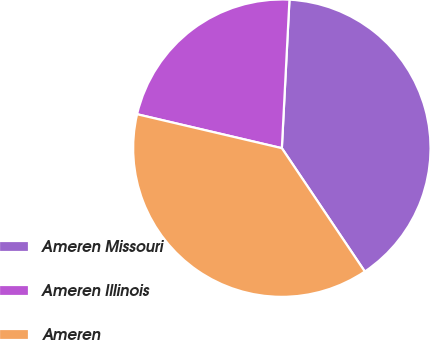Convert chart. <chart><loc_0><loc_0><loc_500><loc_500><pie_chart><fcel>Ameren Missouri<fcel>Ameren Illinois<fcel>Ameren<nl><fcel>39.76%<fcel>22.15%<fcel>38.09%<nl></chart> 